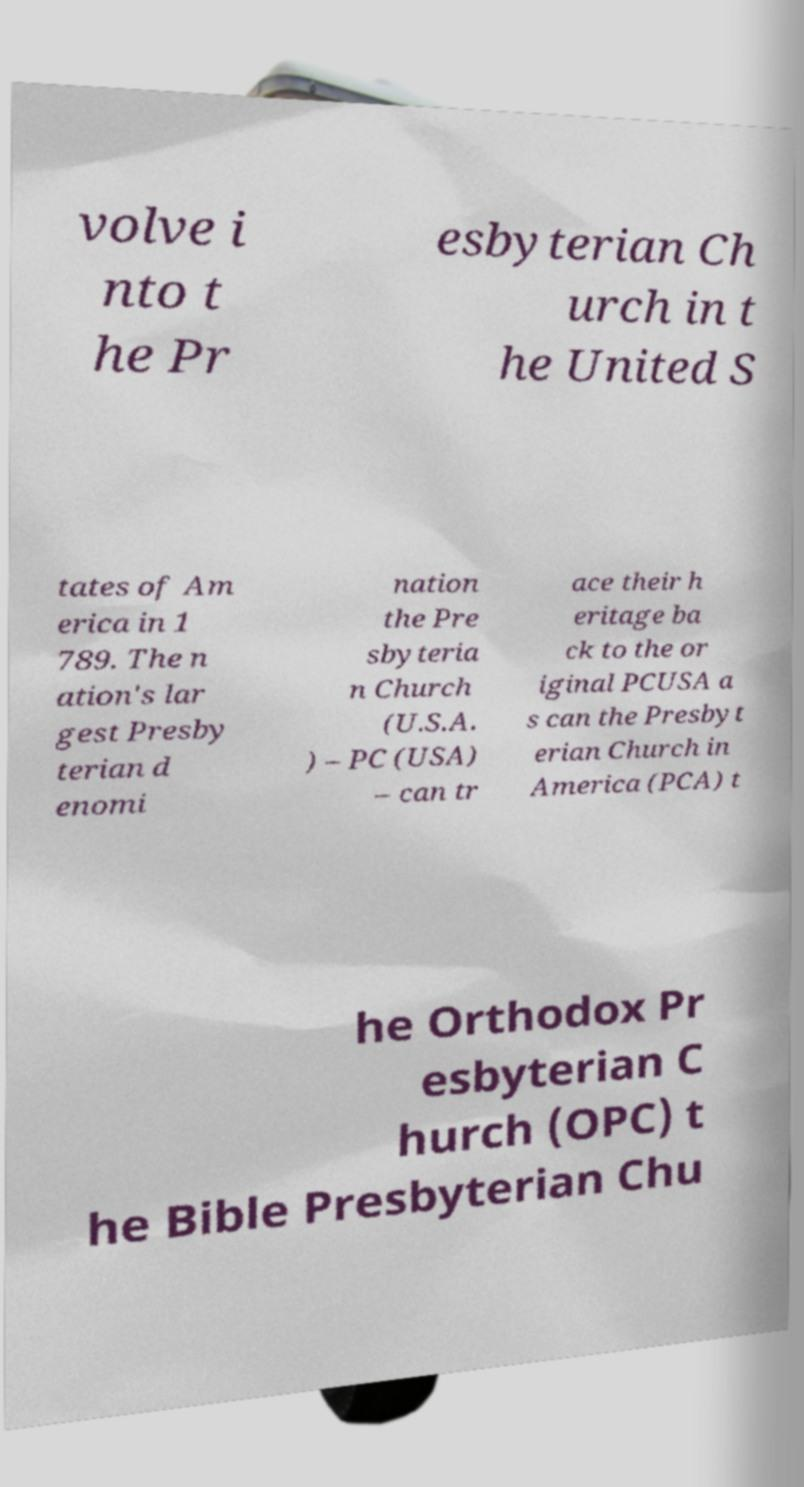There's text embedded in this image that I need extracted. Can you transcribe it verbatim? volve i nto t he Pr esbyterian Ch urch in t he United S tates of Am erica in 1 789. The n ation's lar gest Presby terian d enomi nation the Pre sbyteria n Church (U.S.A. ) – PC (USA) – can tr ace their h eritage ba ck to the or iginal PCUSA a s can the Presbyt erian Church in America (PCA) t he Orthodox Pr esbyterian C hurch (OPC) t he Bible Presbyterian Chu 